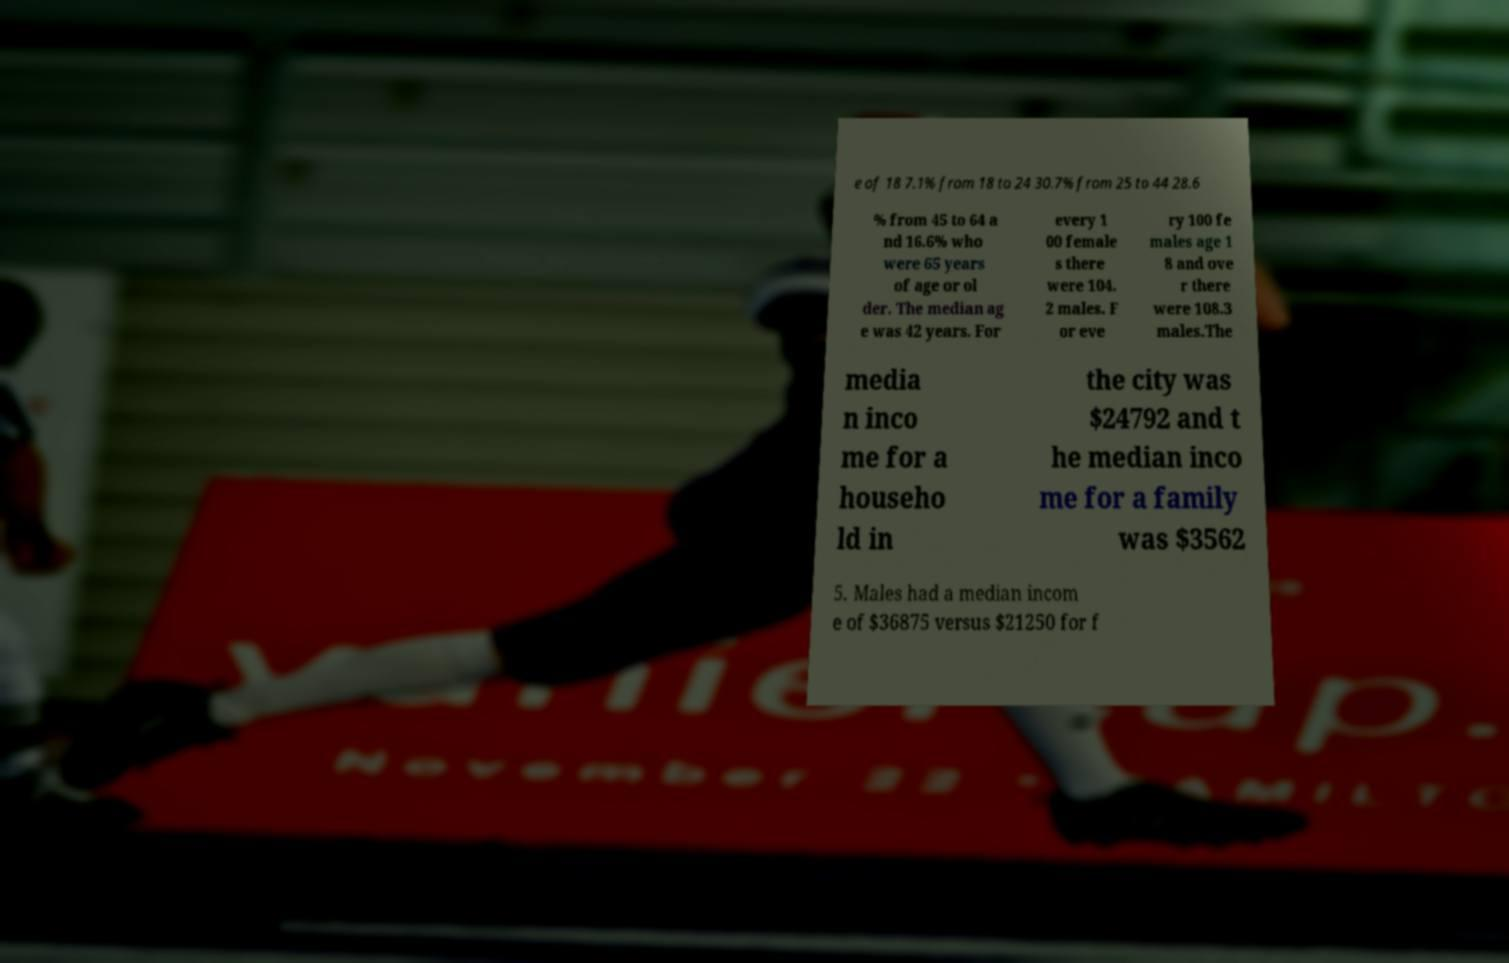Can you read and provide the text displayed in the image?This photo seems to have some interesting text. Can you extract and type it out for me? e of 18 7.1% from 18 to 24 30.7% from 25 to 44 28.6 % from 45 to 64 a nd 16.6% who were 65 years of age or ol der. The median ag e was 42 years. For every 1 00 female s there were 104. 2 males. F or eve ry 100 fe males age 1 8 and ove r there were 108.3 males.The media n inco me for a househo ld in the city was $24792 and t he median inco me for a family was $3562 5. Males had a median incom e of $36875 versus $21250 for f 